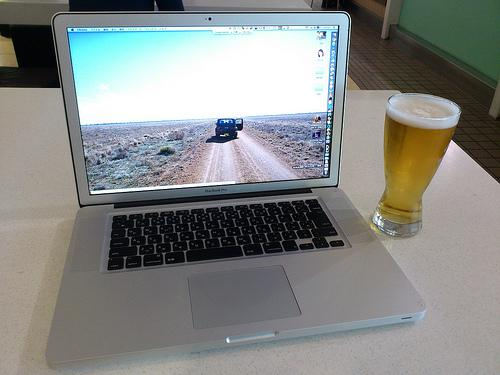Question: what drink is beside the computer?
Choices:
A. Beer.
B. Wine.
C. Milk.
D. Tea.
Answer with the letter. Answer: A Question: what electronic is on the table?
Choices:
A. E-reader.
B. Cell phone.
C. Laptop.
D. Television.
Answer with the letter. Answer: C Question: where is this shot?
Choices:
A. Table.
B. Bar.
C. Counter.
D. Buffet.
Answer with the letter. Answer: A 